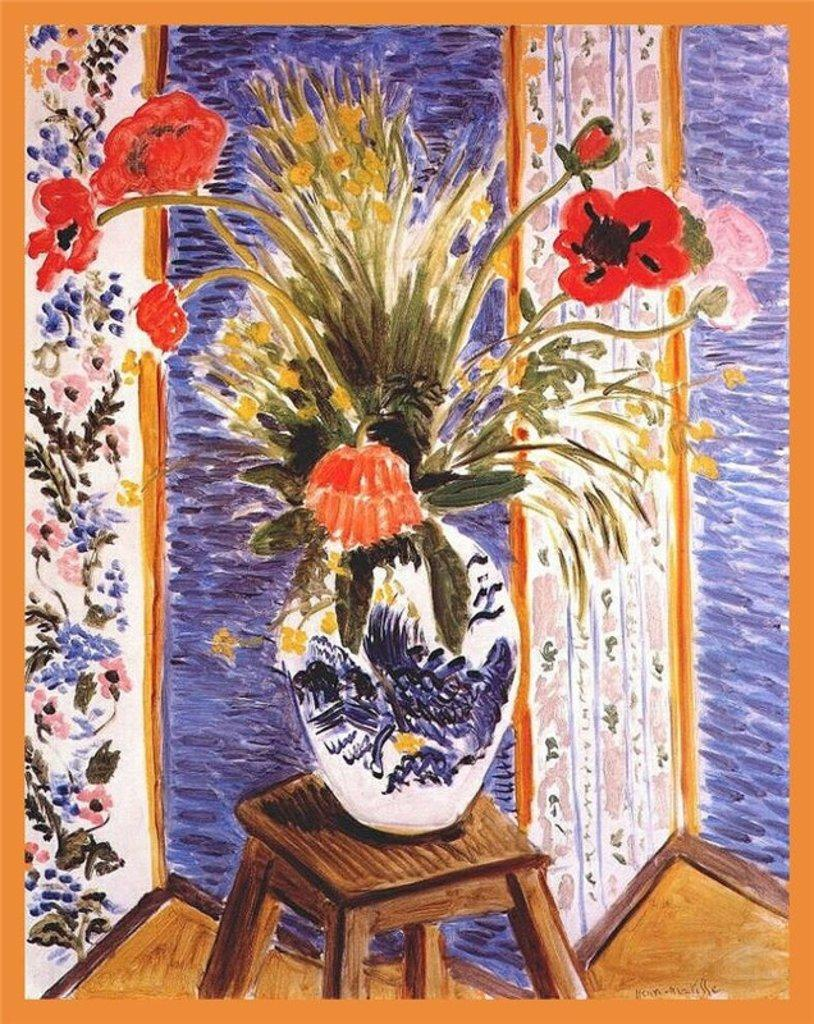What is depicted in the painting in the image? There is a painting of flowers and leaves in a vase in the image. What type of furniture is present in the image? There is a stool in the image. What caption can be seen below the painting in the image? There is no caption visible below the painting in the image. 